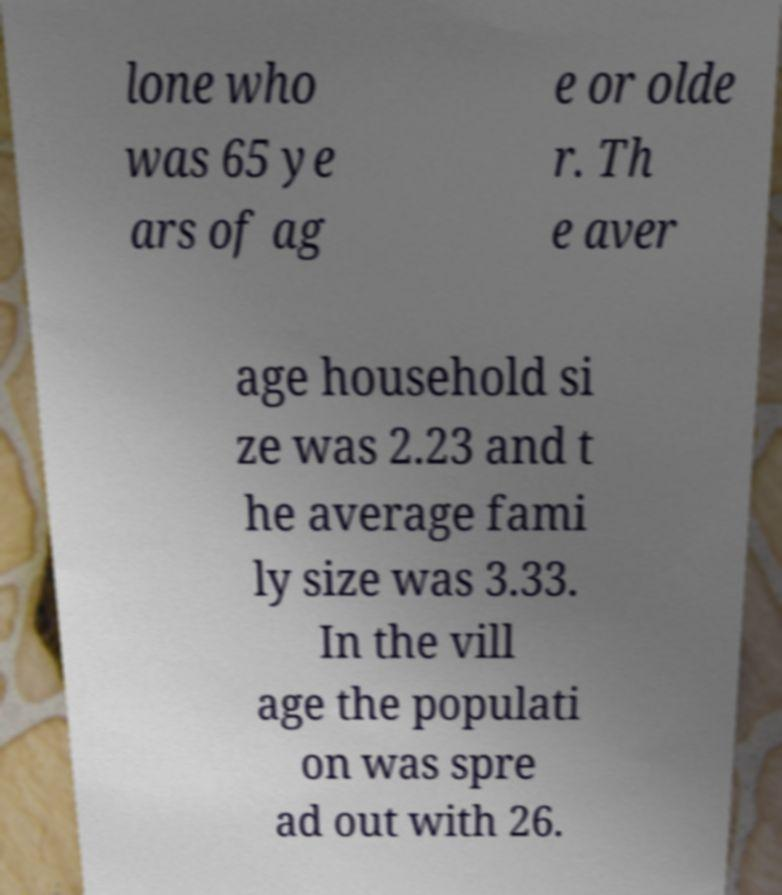Could you extract and type out the text from this image? lone who was 65 ye ars of ag e or olde r. Th e aver age household si ze was 2.23 and t he average fami ly size was 3.33. In the vill age the populati on was spre ad out with 26. 